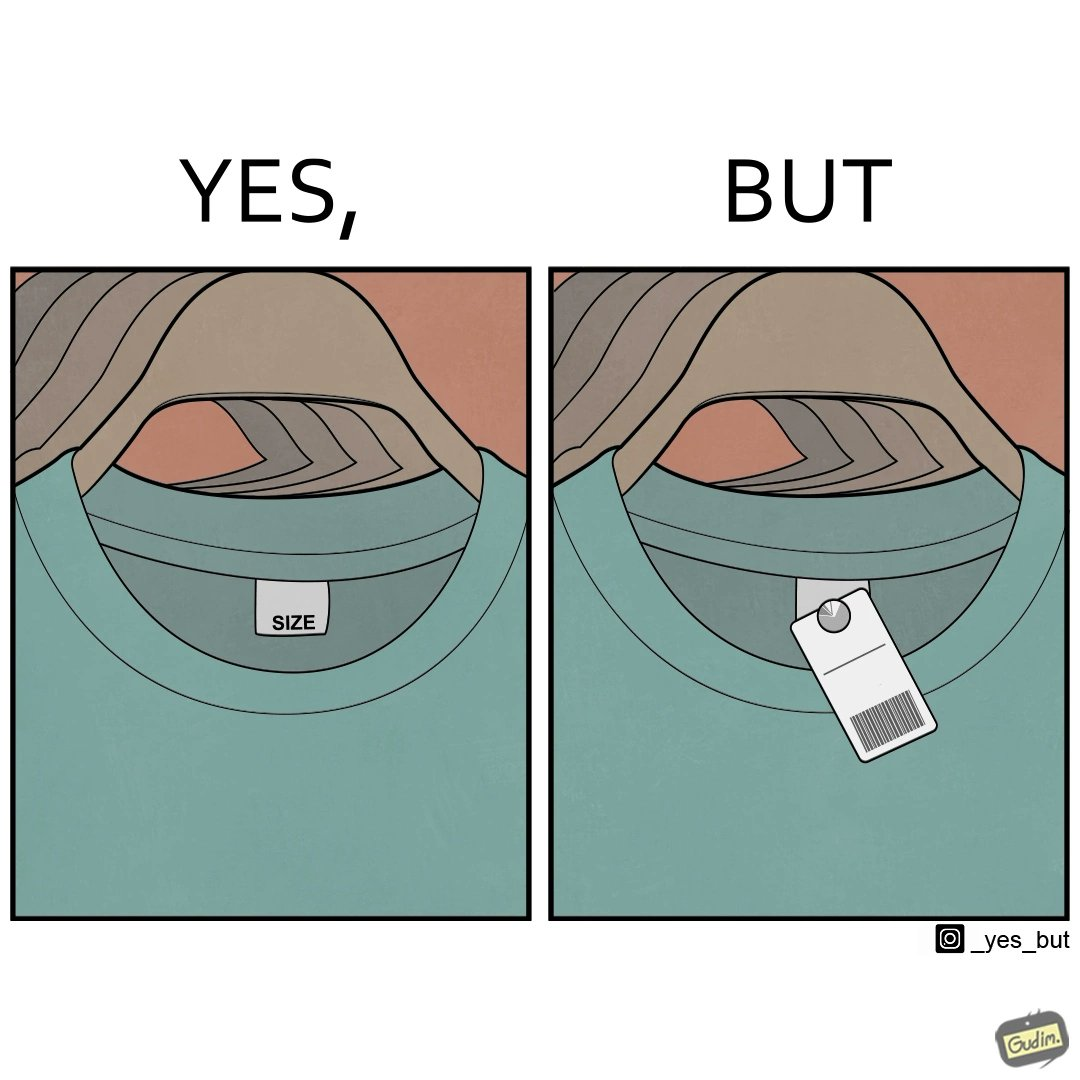Compare the left and right sides of this image. In the left part of the image: some t-shirts of the same type hanging together with size printed on the tag In the right part of the image: some t-shirts of the same type hanging together with some 